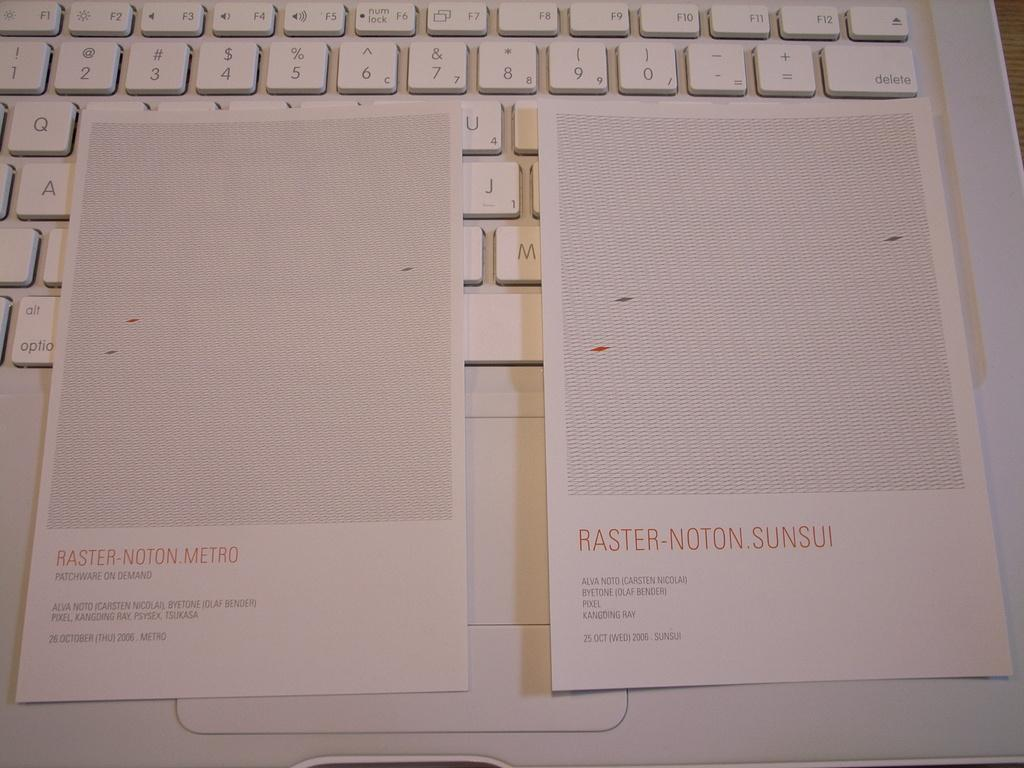Provide a one-sentence caption for the provided image. Two pieces of paper, one the reads, "Raster-Noton.Metro sit on top of a white computer keyboard. 